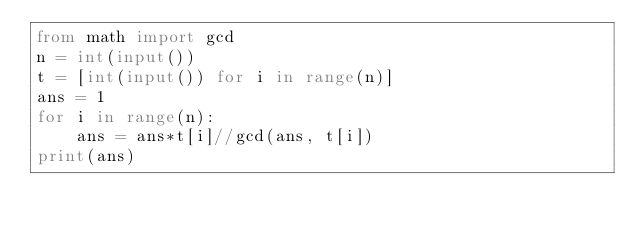Convert code to text. <code><loc_0><loc_0><loc_500><loc_500><_Python_>from math import gcd
n = int(input())
t = [int(input()) for i in range(n)]
ans = 1
for i in range(n):
    ans = ans*t[i]//gcd(ans, t[i])
print(ans)</code> 